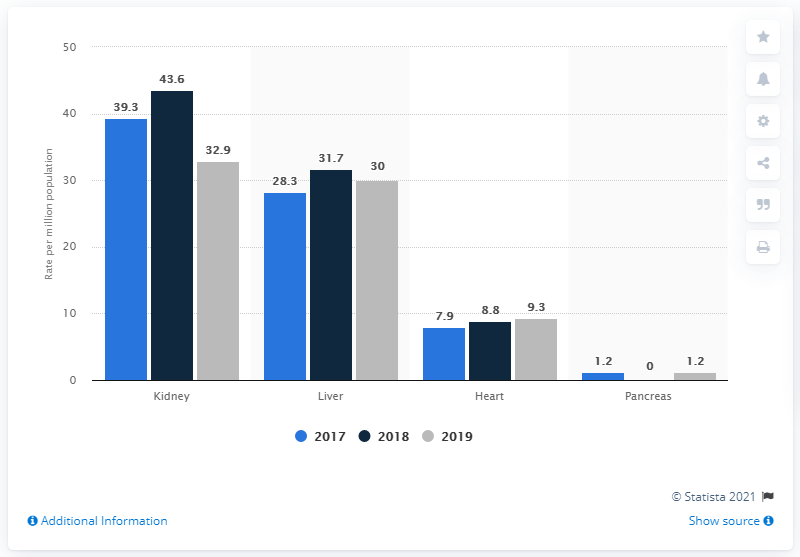Mention a couple of crucial points in this snapshot. The lowest value of grey is 1.2. The highest and lowest gray bar have a difference of 31.7. 